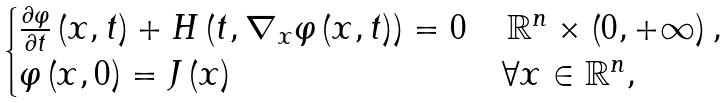Convert formula to latex. <formula><loc_0><loc_0><loc_500><loc_500>\begin{cases} \frac { \partial \varphi } { \partial t } \left ( x , t \right ) + H \left ( t , \nabla _ { x } \varphi \left ( x , t \right ) \right ) = 0 & \, \mathbb { R } ^ { n } \times \left ( 0 , + \infty \right ) , \\ \varphi \left ( x , 0 \right ) = J \left ( x \right ) & \forall x \in \mathbb { R } ^ { n } , \end{cases}</formula> 